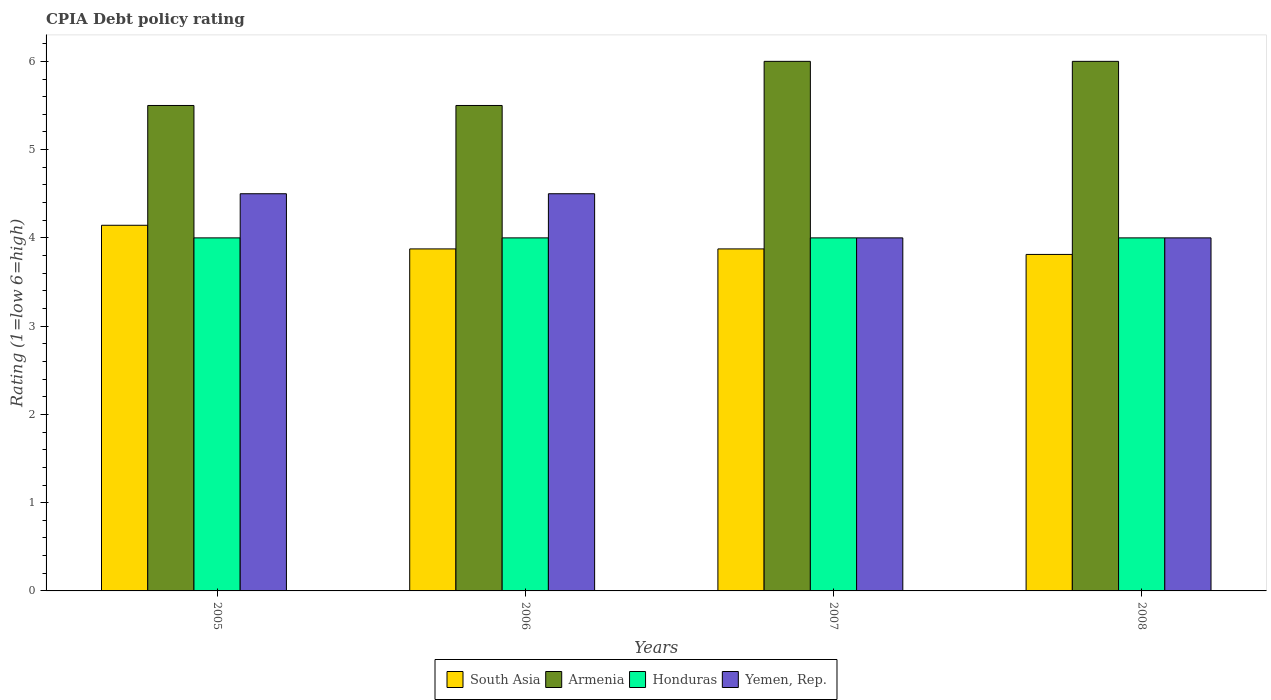How many groups of bars are there?
Offer a terse response. 4. Are the number of bars on each tick of the X-axis equal?
Provide a short and direct response. Yes. How many bars are there on the 1st tick from the left?
Offer a very short reply. 4. How many bars are there on the 4th tick from the right?
Your answer should be very brief. 4. In how many cases, is the number of bars for a given year not equal to the number of legend labels?
Make the answer very short. 0. Across all years, what is the maximum CPIA rating in South Asia?
Make the answer very short. 4.14. Across all years, what is the minimum CPIA rating in South Asia?
Provide a succinct answer. 3.81. In which year was the CPIA rating in Armenia maximum?
Offer a very short reply. 2007. In which year was the CPIA rating in South Asia minimum?
Offer a terse response. 2008. What is the total CPIA rating in Yemen, Rep. in the graph?
Provide a short and direct response. 17. What is the difference between the CPIA rating in Honduras in 2006 and that in 2007?
Your response must be concise. 0. What is the average CPIA rating in South Asia per year?
Offer a terse response. 3.93. In the year 2008, what is the difference between the CPIA rating in Armenia and CPIA rating in Yemen, Rep.?
Offer a very short reply. 2. Is the CPIA rating in Yemen, Rep. in 2005 less than that in 2008?
Provide a short and direct response. No. Is the difference between the CPIA rating in Armenia in 2006 and 2008 greater than the difference between the CPIA rating in Yemen, Rep. in 2006 and 2008?
Offer a very short reply. No. What is the difference between the highest and the lowest CPIA rating in South Asia?
Provide a short and direct response. 0.33. Is it the case that in every year, the sum of the CPIA rating in Honduras and CPIA rating in Armenia is greater than the sum of CPIA rating in Yemen, Rep. and CPIA rating in South Asia?
Ensure brevity in your answer.  Yes. What does the 3rd bar from the left in 2006 represents?
Provide a short and direct response. Honduras. What does the 1st bar from the right in 2007 represents?
Make the answer very short. Yemen, Rep. How many bars are there?
Ensure brevity in your answer.  16. Are all the bars in the graph horizontal?
Your response must be concise. No. Are the values on the major ticks of Y-axis written in scientific E-notation?
Keep it short and to the point. No. Does the graph contain any zero values?
Provide a short and direct response. No. Does the graph contain grids?
Offer a very short reply. No. Where does the legend appear in the graph?
Make the answer very short. Bottom center. How many legend labels are there?
Offer a terse response. 4. How are the legend labels stacked?
Your answer should be very brief. Horizontal. What is the title of the graph?
Your response must be concise. CPIA Debt policy rating. What is the Rating (1=low 6=high) in South Asia in 2005?
Provide a succinct answer. 4.14. What is the Rating (1=low 6=high) in Armenia in 2005?
Your answer should be compact. 5.5. What is the Rating (1=low 6=high) in Yemen, Rep. in 2005?
Your answer should be compact. 4.5. What is the Rating (1=low 6=high) in South Asia in 2006?
Make the answer very short. 3.88. What is the Rating (1=low 6=high) of South Asia in 2007?
Your response must be concise. 3.88. What is the Rating (1=low 6=high) in Armenia in 2007?
Your answer should be compact. 6. What is the Rating (1=low 6=high) of South Asia in 2008?
Keep it short and to the point. 3.81. What is the Rating (1=low 6=high) in Armenia in 2008?
Make the answer very short. 6. What is the Rating (1=low 6=high) in Yemen, Rep. in 2008?
Offer a very short reply. 4. Across all years, what is the maximum Rating (1=low 6=high) of South Asia?
Your answer should be very brief. 4.14. Across all years, what is the maximum Rating (1=low 6=high) of Honduras?
Provide a short and direct response. 4. Across all years, what is the maximum Rating (1=low 6=high) of Yemen, Rep.?
Your answer should be very brief. 4.5. Across all years, what is the minimum Rating (1=low 6=high) in South Asia?
Provide a succinct answer. 3.81. What is the total Rating (1=low 6=high) of South Asia in the graph?
Give a very brief answer. 15.71. What is the total Rating (1=low 6=high) in Armenia in the graph?
Offer a very short reply. 23. What is the difference between the Rating (1=low 6=high) of South Asia in 2005 and that in 2006?
Offer a terse response. 0.27. What is the difference between the Rating (1=low 6=high) of Honduras in 2005 and that in 2006?
Offer a very short reply. 0. What is the difference between the Rating (1=low 6=high) of Yemen, Rep. in 2005 and that in 2006?
Your answer should be very brief. 0. What is the difference between the Rating (1=low 6=high) in South Asia in 2005 and that in 2007?
Ensure brevity in your answer.  0.27. What is the difference between the Rating (1=low 6=high) of Honduras in 2005 and that in 2007?
Provide a succinct answer. 0. What is the difference between the Rating (1=low 6=high) in South Asia in 2005 and that in 2008?
Offer a very short reply. 0.33. What is the difference between the Rating (1=low 6=high) in Armenia in 2005 and that in 2008?
Provide a succinct answer. -0.5. What is the difference between the Rating (1=low 6=high) of Honduras in 2005 and that in 2008?
Offer a very short reply. 0. What is the difference between the Rating (1=low 6=high) in South Asia in 2006 and that in 2008?
Your answer should be compact. 0.06. What is the difference between the Rating (1=low 6=high) in Yemen, Rep. in 2006 and that in 2008?
Provide a succinct answer. 0.5. What is the difference between the Rating (1=low 6=high) of South Asia in 2007 and that in 2008?
Give a very brief answer. 0.06. What is the difference between the Rating (1=low 6=high) of Armenia in 2007 and that in 2008?
Your answer should be compact. 0. What is the difference between the Rating (1=low 6=high) in Yemen, Rep. in 2007 and that in 2008?
Ensure brevity in your answer.  0. What is the difference between the Rating (1=low 6=high) in South Asia in 2005 and the Rating (1=low 6=high) in Armenia in 2006?
Keep it short and to the point. -1.36. What is the difference between the Rating (1=low 6=high) in South Asia in 2005 and the Rating (1=low 6=high) in Honduras in 2006?
Ensure brevity in your answer.  0.14. What is the difference between the Rating (1=low 6=high) of South Asia in 2005 and the Rating (1=low 6=high) of Yemen, Rep. in 2006?
Your response must be concise. -0.36. What is the difference between the Rating (1=low 6=high) in Honduras in 2005 and the Rating (1=low 6=high) in Yemen, Rep. in 2006?
Your answer should be compact. -0.5. What is the difference between the Rating (1=low 6=high) of South Asia in 2005 and the Rating (1=low 6=high) of Armenia in 2007?
Offer a very short reply. -1.86. What is the difference between the Rating (1=low 6=high) in South Asia in 2005 and the Rating (1=low 6=high) in Honduras in 2007?
Your response must be concise. 0.14. What is the difference between the Rating (1=low 6=high) of South Asia in 2005 and the Rating (1=low 6=high) of Yemen, Rep. in 2007?
Your answer should be compact. 0.14. What is the difference between the Rating (1=low 6=high) in Armenia in 2005 and the Rating (1=low 6=high) in Honduras in 2007?
Offer a terse response. 1.5. What is the difference between the Rating (1=low 6=high) in Honduras in 2005 and the Rating (1=low 6=high) in Yemen, Rep. in 2007?
Offer a terse response. 0. What is the difference between the Rating (1=low 6=high) in South Asia in 2005 and the Rating (1=low 6=high) in Armenia in 2008?
Your answer should be compact. -1.86. What is the difference between the Rating (1=low 6=high) in South Asia in 2005 and the Rating (1=low 6=high) in Honduras in 2008?
Your response must be concise. 0.14. What is the difference between the Rating (1=low 6=high) of South Asia in 2005 and the Rating (1=low 6=high) of Yemen, Rep. in 2008?
Offer a terse response. 0.14. What is the difference between the Rating (1=low 6=high) in Armenia in 2005 and the Rating (1=low 6=high) in Honduras in 2008?
Offer a terse response. 1.5. What is the difference between the Rating (1=low 6=high) of Armenia in 2005 and the Rating (1=low 6=high) of Yemen, Rep. in 2008?
Give a very brief answer. 1.5. What is the difference between the Rating (1=low 6=high) of Honduras in 2005 and the Rating (1=low 6=high) of Yemen, Rep. in 2008?
Keep it short and to the point. 0. What is the difference between the Rating (1=low 6=high) in South Asia in 2006 and the Rating (1=low 6=high) in Armenia in 2007?
Keep it short and to the point. -2.12. What is the difference between the Rating (1=low 6=high) of South Asia in 2006 and the Rating (1=low 6=high) of Honduras in 2007?
Your answer should be compact. -0.12. What is the difference between the Rating (1=low 6=high) in South Asia in 2006 and the Rating (1=low 6=high) in Yemen, Rep. in 2007?
Your answer should be compact. -0.12. What is the difference between the Rating (1=low 6=high) in Armenia in 2006 and the Rating (1=low 6=high) in Yemen, Rep. in 2007?
Your answer should be very brief. 1.5. What is the difference between the Rating (1=low 6=high) of Honduras in 2006 and the Rating (1=low 6=high) of Yemen, Rep. in 2007?
Provide a succinct answer. 0. What is the difference between the Rating (1=low 6=high) of South Asia in 2006 and the Rating (1=low 6=high) of Armenia in 2008?
Offer a terse response. -2.12. What is the difference between the Rating (1=low 6=high) in South Asia in 2006 and the Rating (1=low 6=high) in Honduras in 2008?
Offer a very short reply. -0.12. What is the difference between the Rating (1=low 6=high) of South Asia in 2006 and the Rating (1=low 6=high) of Yemen, Rep. in 2008?
Ensure brevity in your answer.  -0.12. What is the difference between the Rating (1=low 6=high) of Armenia in 2006 and the Rating (1=low 6=high) of Honduras in 2008?
Offer a terse response. 1.5. What is the difference between the Rating (1=low 6=high) of Honduras in 2006 and the Rating (1=low 6=high) of Yemen, Rep. in 2008?
Your answer should be very brief. 0. What is the difference between the Rating (1=low 6=high) of South Asia in 2007 and the Rating (1=low 6=high) of Armenia in 2008?
Ensure brevity in your answer.  -2.12. What is the difference between the Rating (1=low 6=high) in South Asia in 2007 and the Rating (1=low 6=high) in Honduras in 2008?
Offer a very short reply. -0.12. What is the difference between the Rating (1=low 6=high) in South Asia in 2007 and the Rating (1=low 6=high) in Yemen, Rep. in 2008?
Give a very brief answer. -0.12. What is the difference between the Rating (1=low 6=high) of Armenia in 2007 and the Rating (1=low 6=high) of Honduras in 2008?
Provide a short and direct response. 2. What is the average Rating (1=low 6=high) of South Asia per year?
Provide a short and direct response. 3.93. What is the average Rating (1=low 6=high) of Armenia per year?
Your answer should be very brief. 5.75. What is the average Rating (1=low 6=high) in Honduras per year?
Provide a short and direct response. 4. What is the average Rating (1=low 6=high) of Yemen, Rep. per year?
Your response must be concise. 4.25. In the year 2005, what is the difference between the Rating (1=low 6=high) of South Asia and Rating (1=low 6=high) of Armenia?
Make the answer very short. -1.36. In the year 2005, what is the difference between the Rating (1=low 6=high) in South Asia and Rating (1=low 6=high) in Honduras?
Offer a terse response. 0.14. In the year 2005, what is the difference between the Rating (1=low 6=high) in South Asia and Rating (1=low 6=high) in Yemen, Rep.?
Keep it short and to the point. -0.36. In the year 2005, what is the difference between the Rating (1=low 6=high) in Armenia and Rating (1=low 6=high) in Honduras?
Give a very brief answer. 1.5. In the year 2005, what is the difference between the Rating (1=low 6=high) of Honduras and Rating (1=low 6=high) of Yemen, Rep.?
Your response must be concise. -0.5. In the year 2006, what is the difference between the Rating (1=low 6=high) of South Asia and Rating (1=low 6=high) of Armenia?
Make the answer very short. -1.62. In the year 2006, what is the difference between the Rating (1=low 6=high) of South Asia and Rating (1=low 6=high) of Honduras?
Offer a very short reply. -0.12. In the year 2006, what is the difference between the Rating (1=low 6=high) of South Asia and Rating (1=low 6=high) of Yemen, Rep.?
Offer a very short reply. -0.62. In the year 2006, what is the difference between the Rating (1=low 6=high) in Armenia and Rating (1=low 6=high) in Yemen, Rep.?
Your response must be concise. 1. In the year 2006, what is the difference between the Rating (1=low 6=high) of Honduras and Rating (1=low 6=high) of Yemen, Rep.?
Offer a terse response. -0.5. In the year 2007, what is the difference between the Rating (1=low 6=high) in South Asia and Rating (1=low 6=high) in Armenia?
Make the answer very short. -2.12. In the year 2007, what is the difference between the Rating (1=low 6=high) in South Asia and Rating (1=low 6=high) in Honduras?
Your answer should be very brief. -0.12. In the year 2007, what is the difference between the Rating (1=low 6=high) in South Asia and Rating (1=low 6=high) in Yemen, Rep.?
Make the answer very short. -0.12. In the year 2008, what is the difference between the Rating (1=low 6=high) in South Asia and Rating (1=low 6=high) in Armenia?
Your answer should be compact. -2.19. In the year 2008, what is the difference between the Rating (1=low 6=high) of South Asia and Rating (1=low 6=high) of Honduras?
Give a very brief answer. -0.19. In the year 2008, what is the difference between the Rating (1=low 6=high) in South Asia and Rating (1=low 6=high) in Yemen, Rep.?
Your response must be concise. -0.19. In the year 2008, what is the difference between the Rating (1=low 6=high) of Armenia and Rating (1=low 6=high) of Yemen, Rep.?
Your answer should be compact. 2. In the year 2008, what is the difference between the Rating (1=low 6=high) of Honduras and Rating (1=low 6=high) of Yemen, Rep.?
Provide a succinct answer. 0. What is the ratio of the Rating (1=low 6=high) in South Asia in 2005 to that in 2006?
Ensure brevity in your answer.  1.07. What is the ratio of the Rating (1=low 6=high) in South Asia in 2005 to that in 2007?
Offer a very short reply. 1.07. What is the ratio of the Rating (1=low 6=high) of South Asia in 2005 to that in 2008?
Your answer should be very brief. 1.09. What is the ratio of the Rating (1=low 6=high) of South Asia in 2006 to that in 2007?
Ensure brevity in your answer.  1. What is the ratio of the Rating (1=low 6=high) of Armenia in 2006 to that in 2007?
Make the answer very short. 0.92. What is the ratio of the Rating (1=low 6=high) of Yemen, Rep. in 2006 to that in 2007?
Give a very brief answer. 1.12. What is the ratio of the Rating (1=low 6=high) of South Asia in 2006 to that in 2008?
Make the answer very short. 1.02. What is the ratio of the Rating (1=low 6=high) of Armenia in 2006 to that in 2008?
Your answer should be compact. 0.92. What is the ratio of the Rating (1=low 6=high) of Honduras in 2006 to that in 2008?
Your answer should be very brief. 1. What is the ratio of the Rating (1=low 6=high) in Yemen, Rep. in 2006 to that in 2008?
Offer a terse response. 1.12. What is the ratio of the Rating (1=low 6=high) in South Asia in 2007 to that in 2008?
Your response must be concise. 1.02. What is the ratio of the Rating (1=low 6=high) of Armenia in 2007 to that in 2008?
Your answer should be very brief. 1. What is the ratio of the Rating (1=low 6=high) of Honduras in 2007 to that in 2008?
Provide a short and direct response. 1. What is the ratio of the Rating (1=low 6=high) of Yemen, Rep. in 2007 to that in 2008?
Give a very brief answer. 1. What is the difference between the highest and the second highest Rating (1=low 6=high) in South Asia?
Give a very brief answer. 0.27. What is the difference between the highest and the second highest Rating (1=low 6=high) in Armenia?
Your answer should be compact. 0. What is the difference between the highest and the second highest Rating (1=low 6=high) of Yemen, Rep.?
Ensure brevity in your answer.  0. What is the difference between the highest and the lowest Rating (1=low 6=high) in South Asia?
Offer a terse response. 0.33. What is the difference between the highest and the lowest Rating (1=low 6=high) of Armenia?
Give a very brief answer. 0.5. 